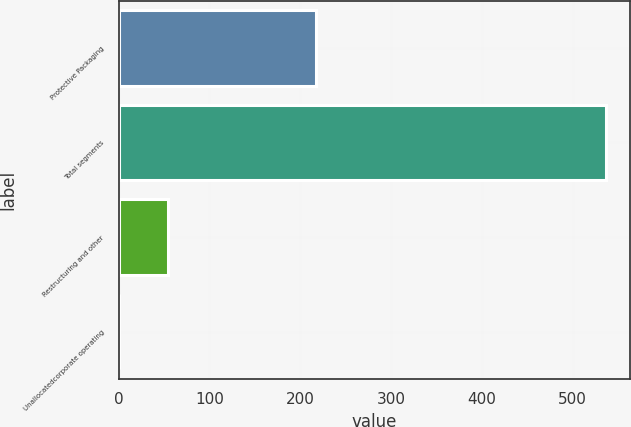<chart> <loc_0><loc_0><loc_500><loc_500><bar_chart><fcel>Protective Packaging<fcel>Total segments<fcel>Restructuring and other<fcel>Unallocatedcorporate operating<nl><fcel>217.6<fcel>536.9<fcel>54.5<fcel>0.9<nl></chart> 